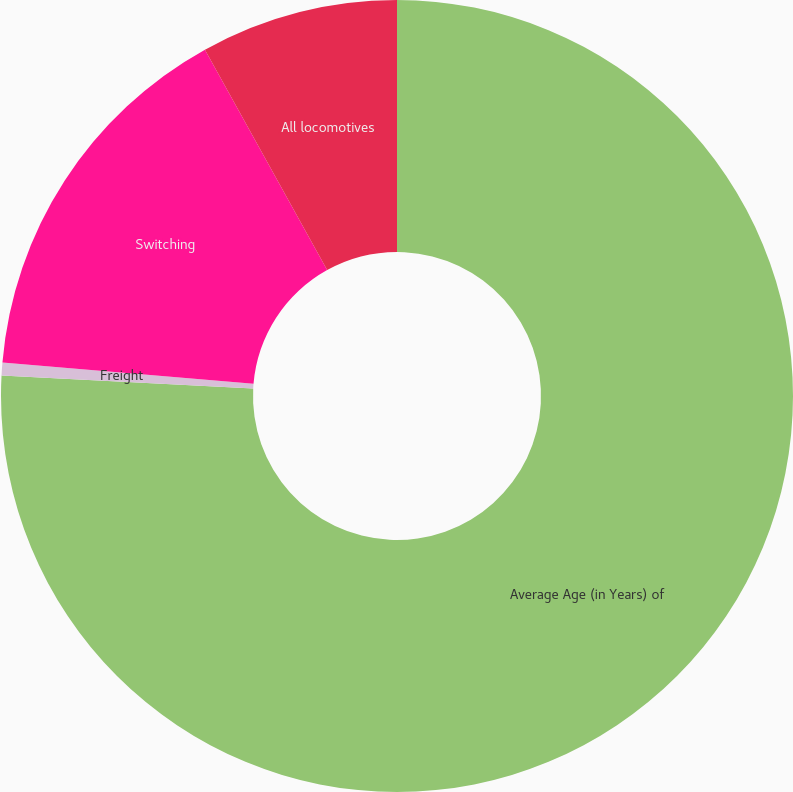Convert chart. <chart><loc_0><loc_0><loc_500><loc_500><pie_chart><fcel>Average Age (in Years) of<fcel>Freight<fcel>Switching<fcel>All locomotives<nl><fcel>75.83%<fcel>0.53%<fcel>15.59%<fcel>8.06%<nl></chart> 